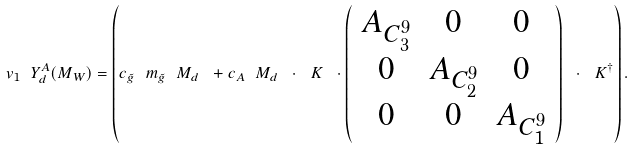Convert formula to latex. <formula><loc_0><loc_0><loc_500><loc_500>v _ { 1 } \ Y ^ { A } _ { d } ( M _ { W } ) = \left ( c _ { \tilde { g } } \ m _ { \tilde { g } } \ M _ { d } \ + c _ { A } \ M _ { d } \ \cdot \ K \ \cdot \left ( \begin{array} { c c c } A _ { C ^ { 9 } _ { 3 } } & 0 & 0 \\ 0 & A _ { C ^ { 9 } _ { 2 } } & 0 \\ 0 & 0 & A _ { C ^ { 9 } _ { 1 } } \end{array} \right ) \ \cdot \ K ^ { \dagger } \right ) .</formula> 